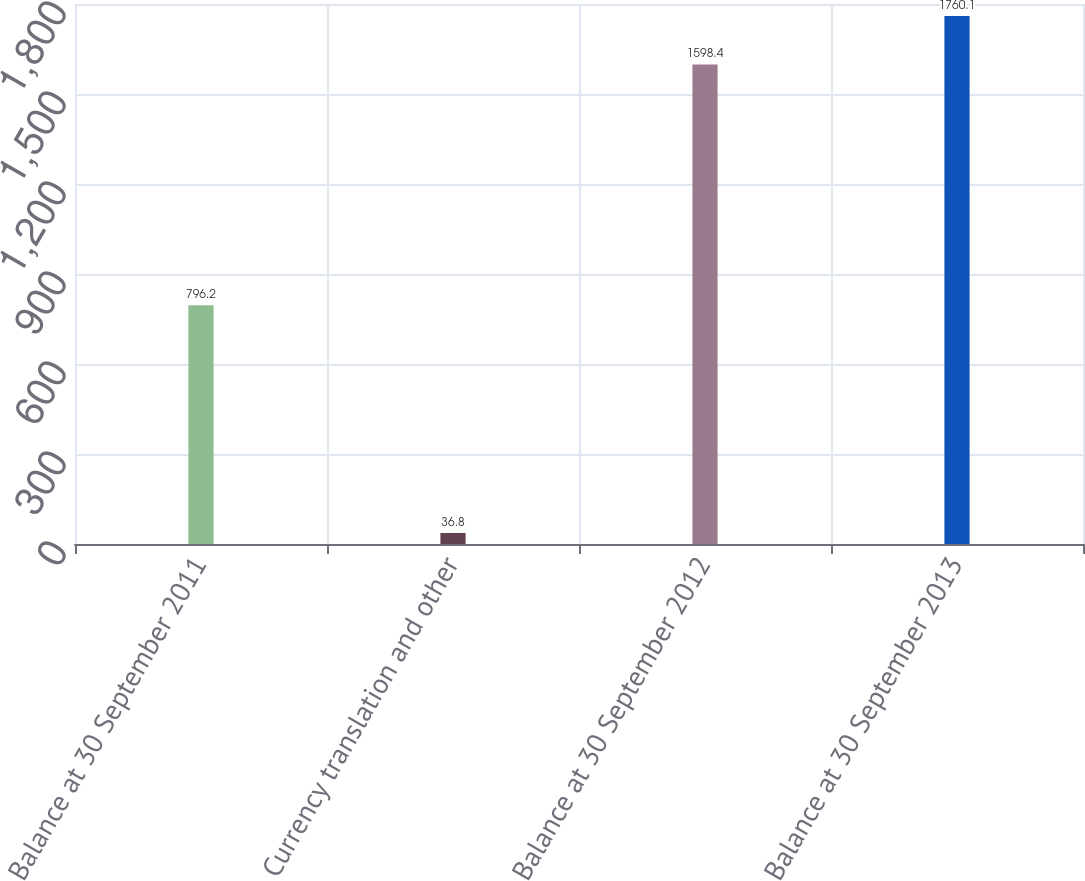<chart> <loc_0><loc_0><loc_500><loc_500><bar_chart><fcel>Balance at 30 September 2011<fcel>Currency translation and other<fcel>Balance at 30 September 2012<fcel>Balance at 30 September 2013<nl><fcel>796.2<fcel>36.8<fcel>1598.4<fcel>1760.1<nl></chart> 